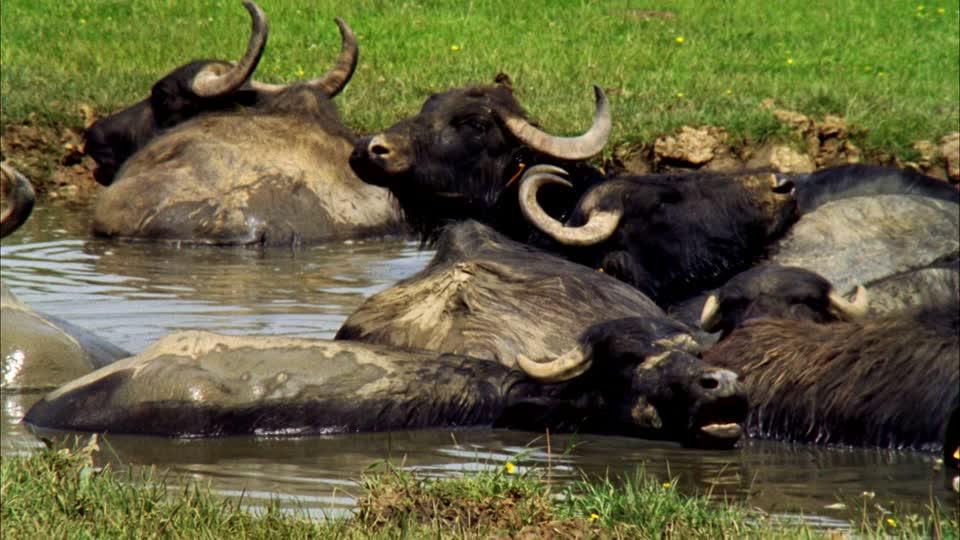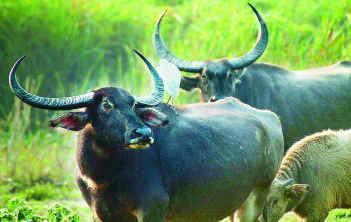The first image is the image on the left, the second image is the image on the right. Considering the images on both sides, is "A buffalo is completely covered in mud." valid? Answer yes or no. No. 